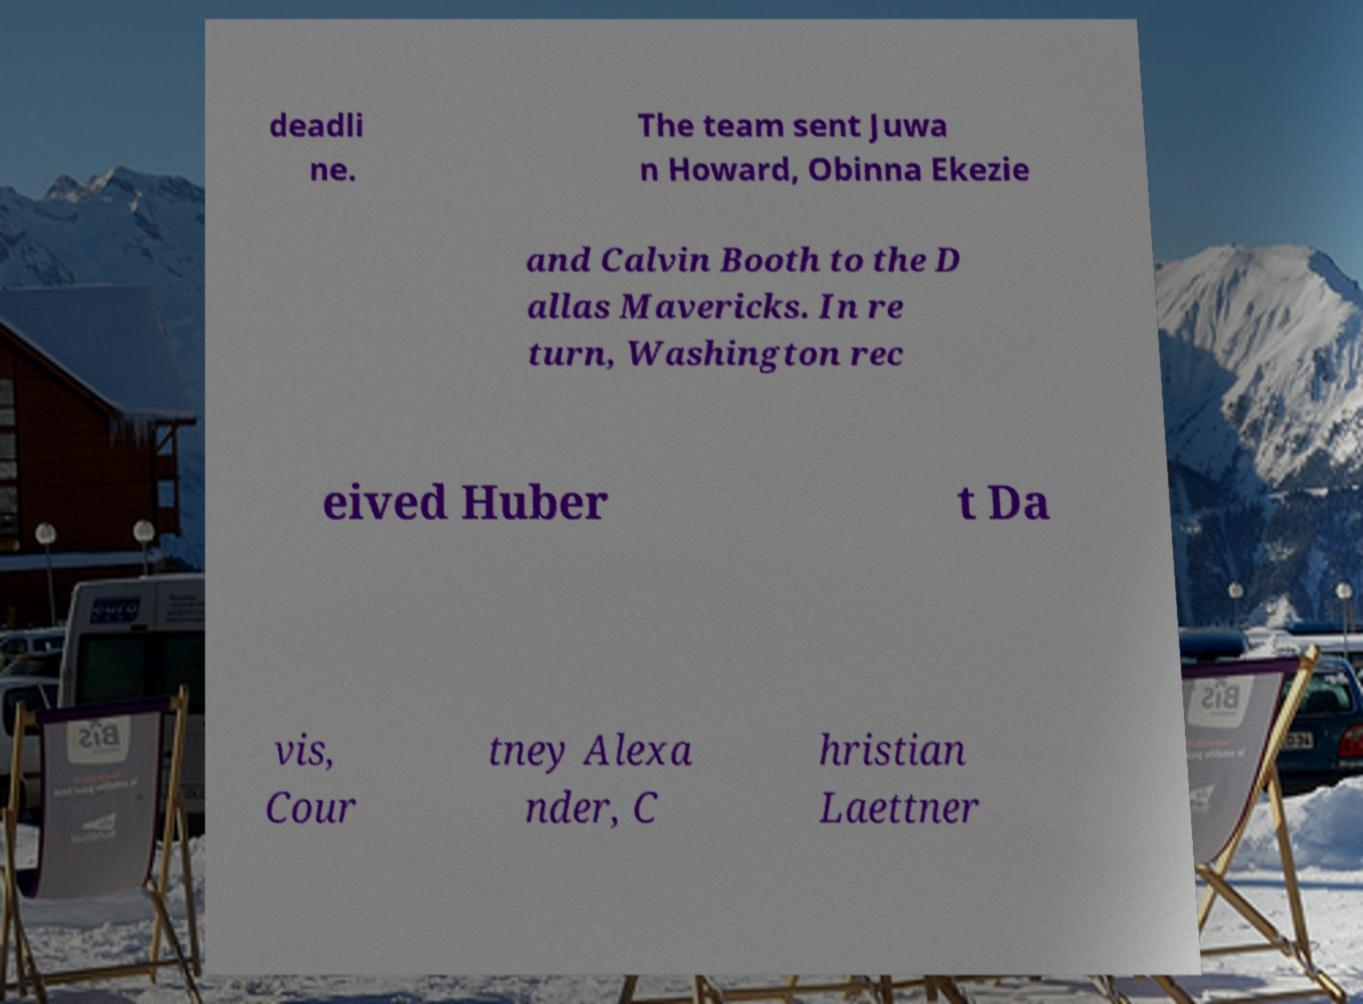Please read and relay the text visible in this image. What does it say? deadli ne. The team sent Juwa n Howard, Obinna Ekezie and Calvin Booth to the D allas Mavericks. In re turn, Washington rec eived Huber t Da vis, Cour tney Alexa nder, C hristian Laettner 